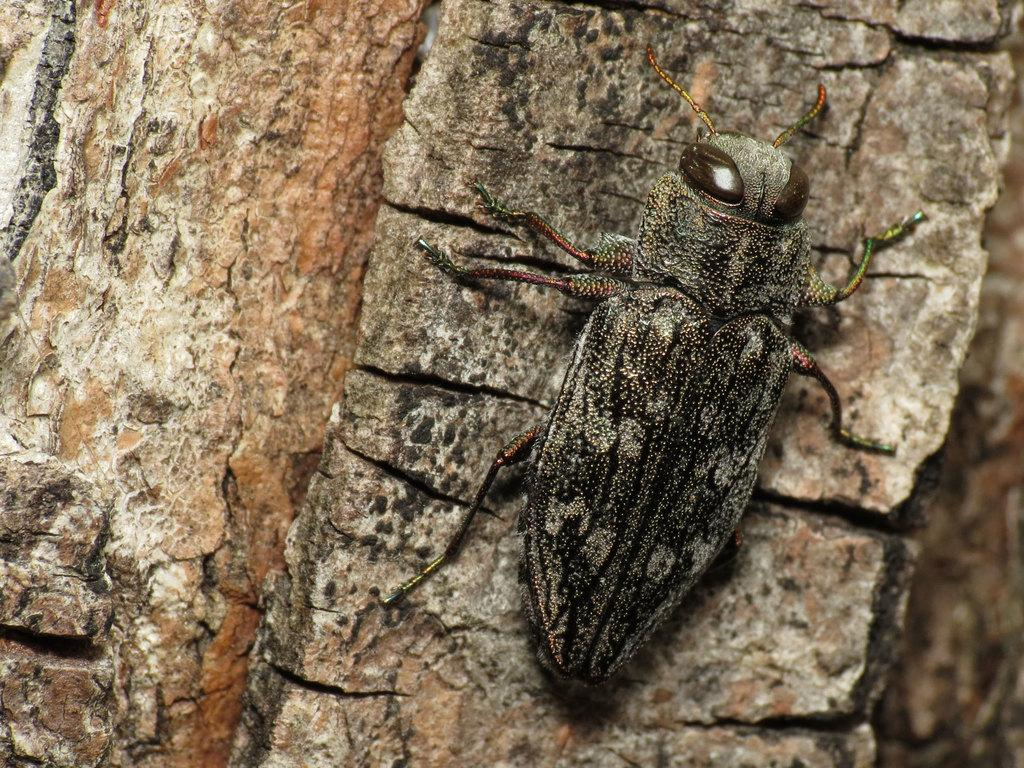What type of creature can be seen in the image? There is an insect in the image. What is the insect attached to in the image? The insect is attached to a wooden trunk. What type of amusement can be seen in the image? There is no amusement present in the image; it features an insect attached to a wooden trunk. What type of card is visible in the image? There is no card present in the image. What is the plot of the story depicted in the image? There is no story depicted in the image; it simply shows an insect attached to a wooden trunk. 